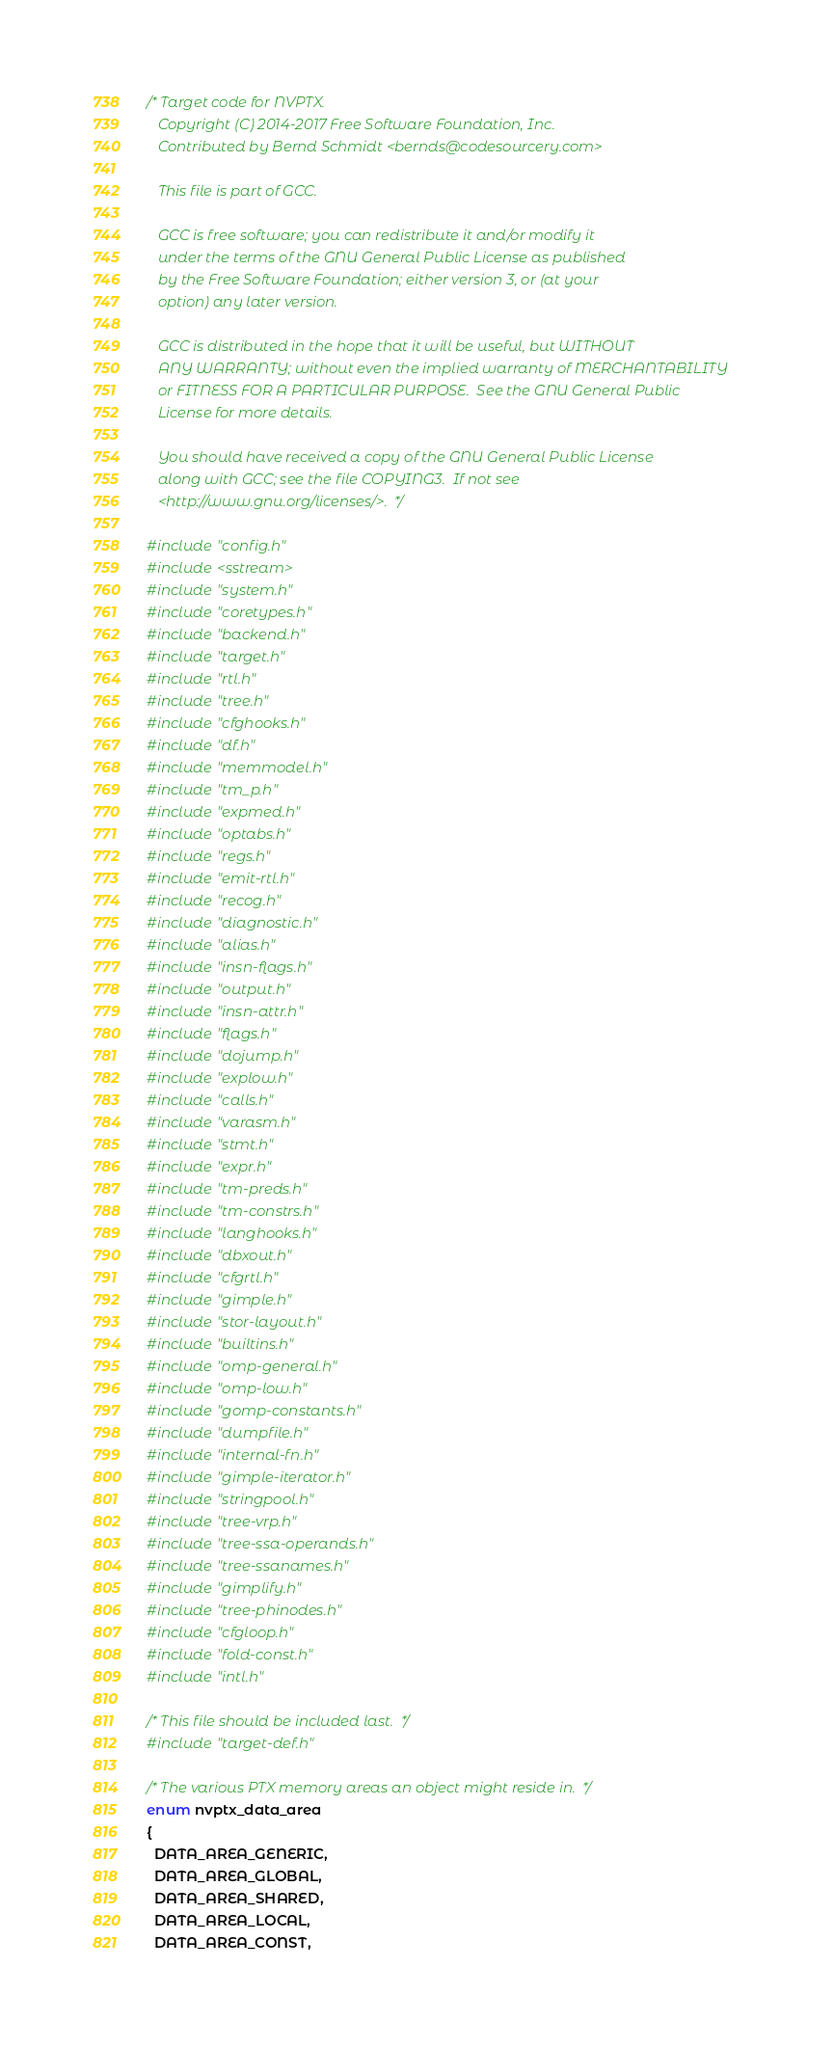<code> <loc_0><loc_0><loc_500><loc_500><_C_>/* Target code for NVPTX.
   Copyright (C) 2014-2017 Free Software Foundation, Inc.
   Contributed by Bernd Schmidt <bernds@codesourcery.com>

   This file is part of GCC.

   GCC is free software; you can redistribute it and/or modify it
   under the terms of the GNU General Public License as published
   by the Free Software Foundation; either version 3, or (at your
   option) any later version.

   GCC is distributed in the hope that it will be useful, but WITHOUT
   ANY WARRANTY; without even the implied warranty of MERCHANTABILITY
   or FITNESS FOR A PARTICULAR PURPOSE.  See the GNU General Public
   License for more details.

   You should have received a copy of the GNU General Public License
   along with GCC; see the file COPYING3.  If not see
   <http://www.gnu.org/licenses/>.  */

#include "config.h"
#include <sstream>
#include "system.h"
#include "coretypes.h"
#include "backend.h"
#include "target.h"
#include "rtl.h"
#include "tree.h"
#include "cfghooks.h"
#include "df.h"
#include "memmodel.h"
#include "tm_p.h"
#include "expmed.h"
#include "optabs.h"
#include "regs.h"
#include "emit-rtl.h"
#include "recog.h"
#include "diagnostic.h"
#include "alias.h"
#include "insn-flags.h"
#include "output.h"
#include "insn-attr.h"
#include "flags.h"
#include "dojump.h"
#include "explow.h"
#include "calls.h"
#include "varasm.h"
#include "stmt.h"
#include "expr.h"
#include "tm-preds.h"
#include "tm-constrs.h"
#include "langhooks.h"
#include "dbxout.h"
#include "cfgrtl.h"
#include "gimple.h"
#include "stor-layout.h"
#include "builtins.h"
#include "omp-general.h"
#include "omp-low.h"
#include "gomp-constants.h"
#include "dumpfile.h"
#include "internal-fn.h"
#include "gimple-iterator.h"
#include "stringpool.h"
#include "tree-vrp.h"
#include "tree-ssa-operands.h"
#include "tree-ssanames.h"
#include "gimplify.h"
#include "tree-phinodes.h"
#include "cfgloop.h"
#include "fold-const.h"
#include "intl.h"

/* This file should be included last.  */
#include "target-def.h"

/* The various PTX memory areas an object might reside in.  */
enum nvptx_data_area
{
  DATA_AREA_GENERIC,
  DATA_AREA_GLOBAL,
  DATA_AREA_SHARED,
  DATA_AREA_LOCAL,
  DATA_AREA_CONST,</code> 